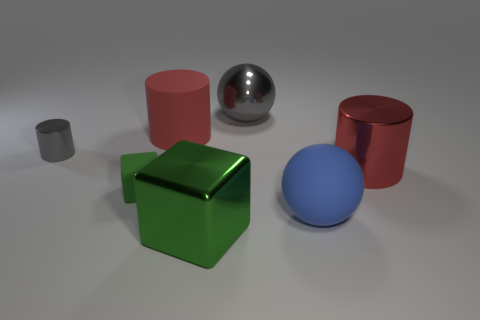Add 1 green blocks. How many objects exist? 8 Subtract all cylinders. How many objects are left? 4 Subtract 0 yellow cubes. How many objects are left? 7 Subtract all large blue rubber objects. Subtract all shiny things. How many objects are left? 2 Add 1 blocks. How many blocks are left? 3 Add 7 big matte cylinders. How many big matte cylinders exist? 8 